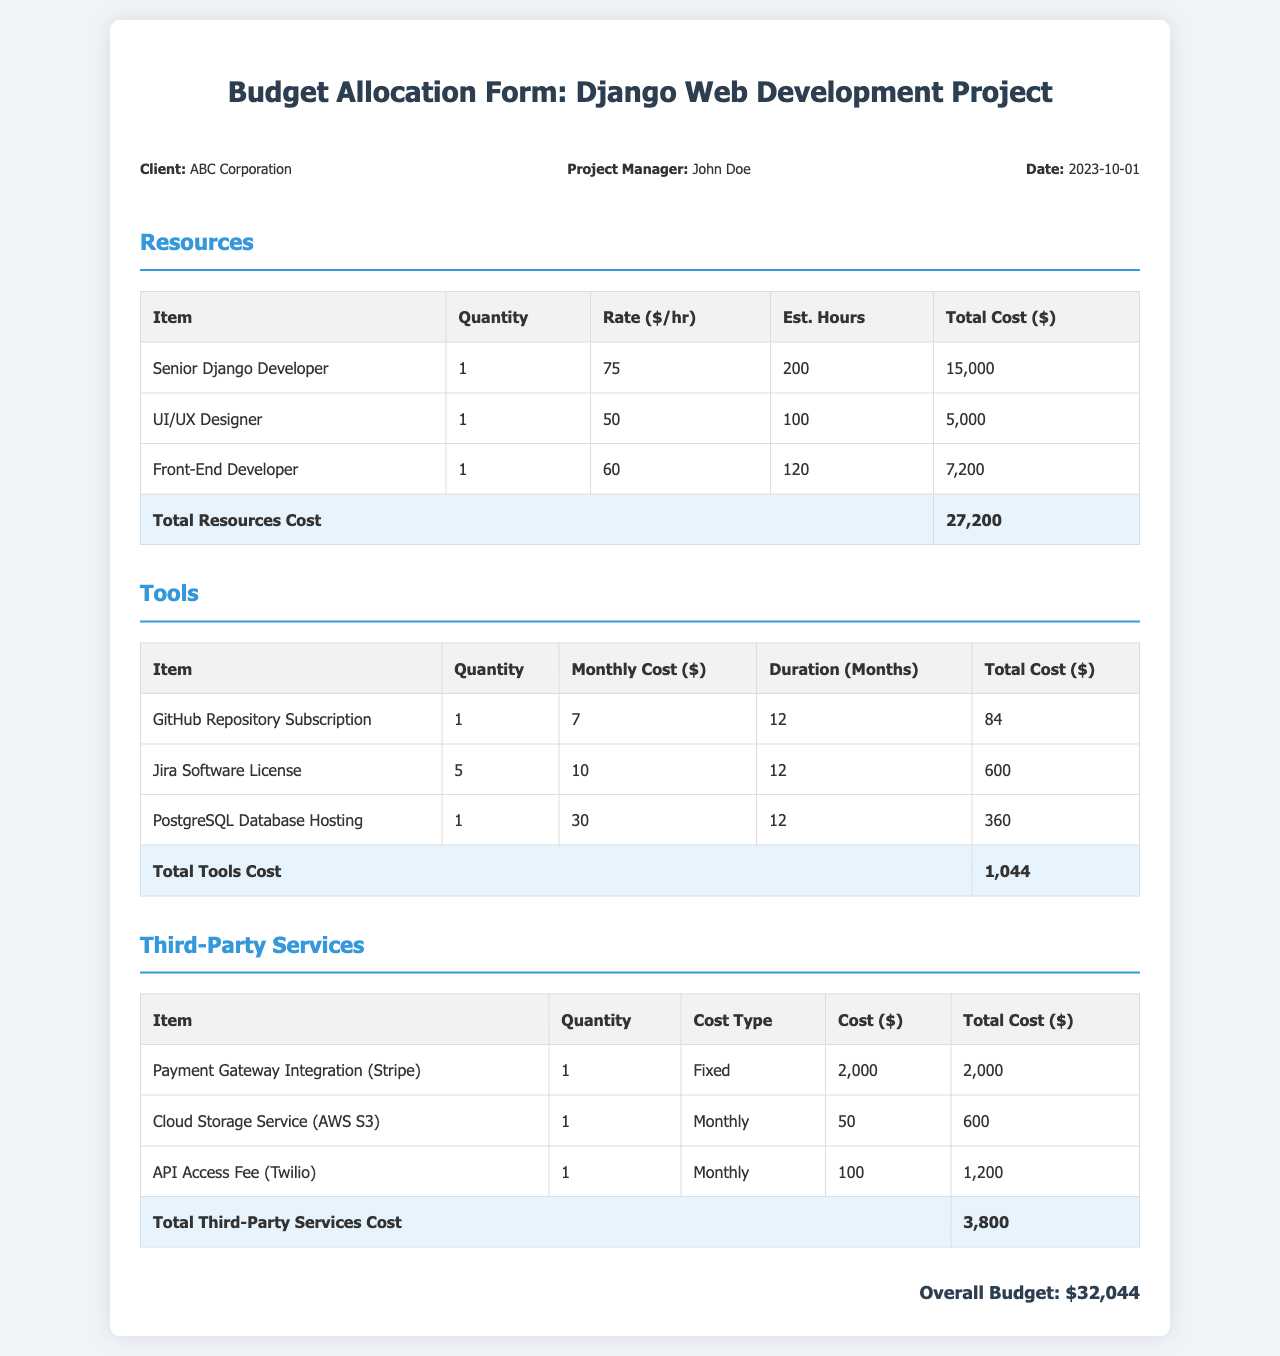What is the client's name? The client's name is stated at the beginning of the document under project info.
Answer: ABC Corporation How many hours are estimated for the Senior Django Developer? The estimated hours for the Senior Django Developer is shown in the Resources section of the document.
Answer: 200 What is the total cost of tools? The total cost of tools is presented in the Tools section, clearly labeled.
Answer: 1,044 What is the monthly cost of the Payment Gateway Integration? The monthly cost for the Payment Gateway Integration is specified in the Third-Party Services section.
Answer: 2,000 What is the overall budget for the project? The overall budget is summarized at the end of the document.
Answer: 32,044 How many UI/UX Designers are included in the budget? The number of UI/UX Designers is listed in the Resources table.
Answer: 1 What organization does the project manager work for? This information is inferred from the context of the project manager's role in the document.
Answer: ABC Corporation What is the cost type for the Cloud Storage Service? The cost type is indicated in the Third-Party Services table.
Answer: Monthly How many Jira Software Licenses are accounted for? The quantity of Jira Software Licenses is specified in the Tools section of the document.
Answer: 5 